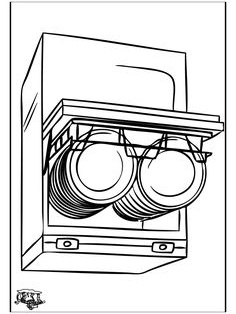Can you explain how the object in this image contributes to a typical kitchen workflow? The dishwasher, as shown in the image, significantly contributes to kitchen efficiency by automating the process of washing dishes. It frees up time for other cooking or cleaning tasks and helps maintain a hygienic environment by ensuring dishes are thoroughly cleaned and sanitized, usually at higher temperatures than hand washing. 